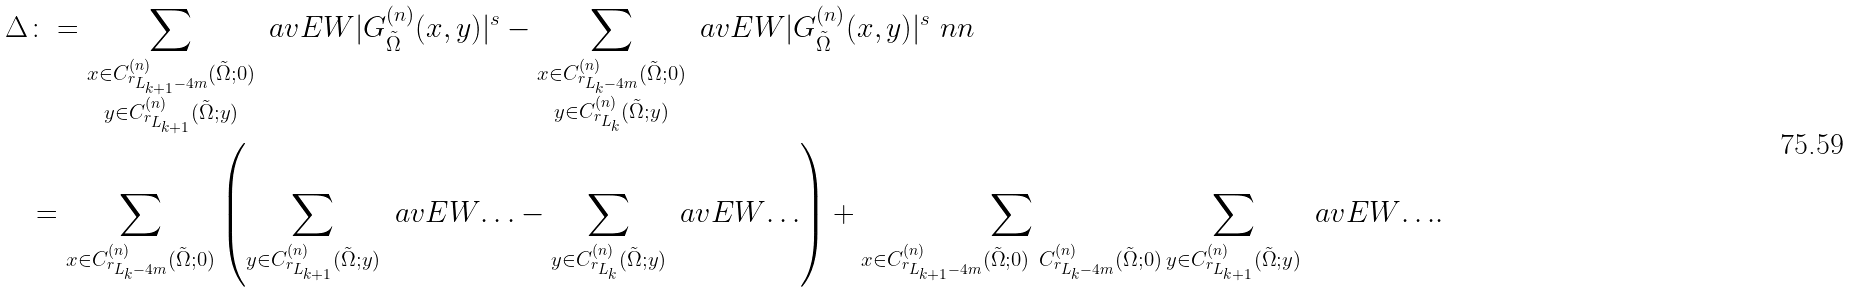Convert formula to latex. <formula><loc_0><loc_0><loc_500><loc_500>\Delta & \colon = \sum _ { \substack { x \in C ^ { ( n ) } _ { r _ { L _ { k + 1 } - 4 m } } ( \tilde { \Omega } ; 0 ) \\ y \in C ^ { ( n ) } _ { r _ { L _ { k + 1 } } } ( \tilde { \Omega } ; y ) } } \ a v E W { | G ^ { ( n ) } _ { \tilde { \Omega } } ( x , y ) | ^ { s } } - \sum _ { \substack { x \in C ^ { ( n ) } _ { r _ { L _ { k } - 4 m } } ( \tilde { \Omega } ; 0 ) \\ y \in C ^ { ( n ) } _ { r _ { L _ { k } } } ( \tilde { \Omega } ; y ) } } \ a v E W { | G ^ { ( n ) } _ { \tilde { \Omega } } ( x , y ) | ^ { s } } \ n n \\ & = \sum _ { x \in C ^ { ( n ) } _ { r _ { L _ { k } - 4 m } } ( \tilde { \Omega } ; 0 ) } \left ( \sum _ { y \in C ^ { ( n ) } _ { r _ { L _ { k + 1 } } } ( \tilde { \Omega } ; y ) } \ a v E W { \dots } - \sum _ { y \in C ^ { ( n ) } _ { r _ { L _ { k } } } ( \tilde { \Omega } ; y ) } \ a v E W { \dots } \right ) + \sum _ { x \in C ^ { ( n ) } _ { r _ { L _ { k + 1 } - 4 m } } ( \tilde { \Omega } ; 0 ) \ C ^ { ( n ) } _ { r _ { L _ { k } - 4 m } } ( \tilde { \Omega } ; 0 ) } \sum _ { y \in C ^ { ( n ) } _ { r _ { L _ { k + 1 } } } ( \tilde { \Omega } ; y ) } \ a v E W { \dots } .</formula> 